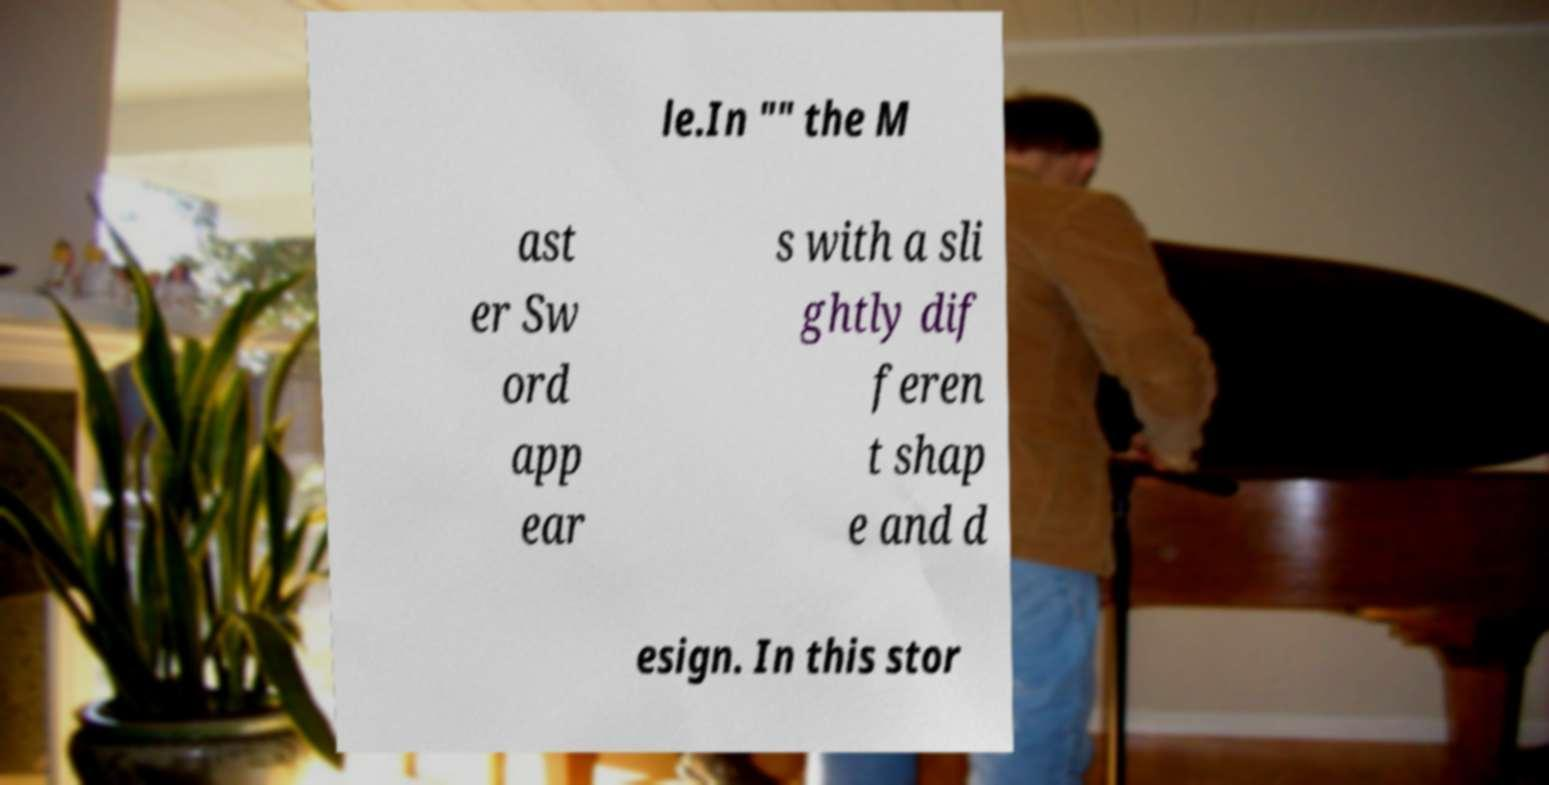Please read and relay the text visible in this image. What does it say? le.In "" the M ast er Sw ord app ear s with a sli ghtly dif feren t shap e and d esign. In this stor 